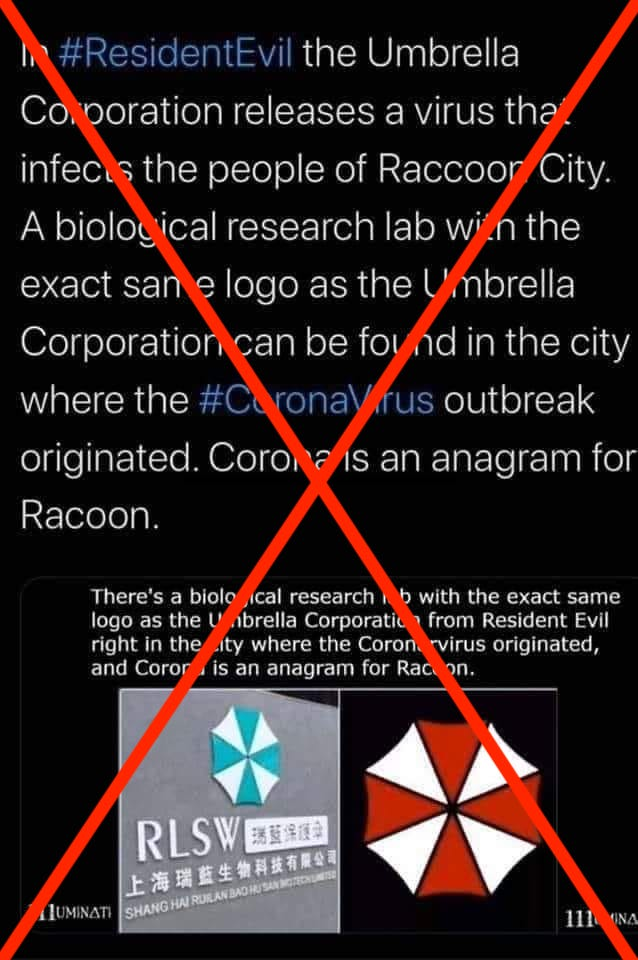Why are conspiracy theories like the one shown in this image so appealing to some people? Conspiracy theories often provide simplified explanations for complex events, which can be appealing because they offer a sense of understanding and control over situations that are uncertain or frightening. They can also reaffirm existing beliefs or biases, giving individuals a communal sense of 'insider' knowledge that separates them from the mainstream narrative. Furthermore, in the age of social media, such theories can spread rapidly and gain traction among communities that trust and reinforce these alternative explanations. 